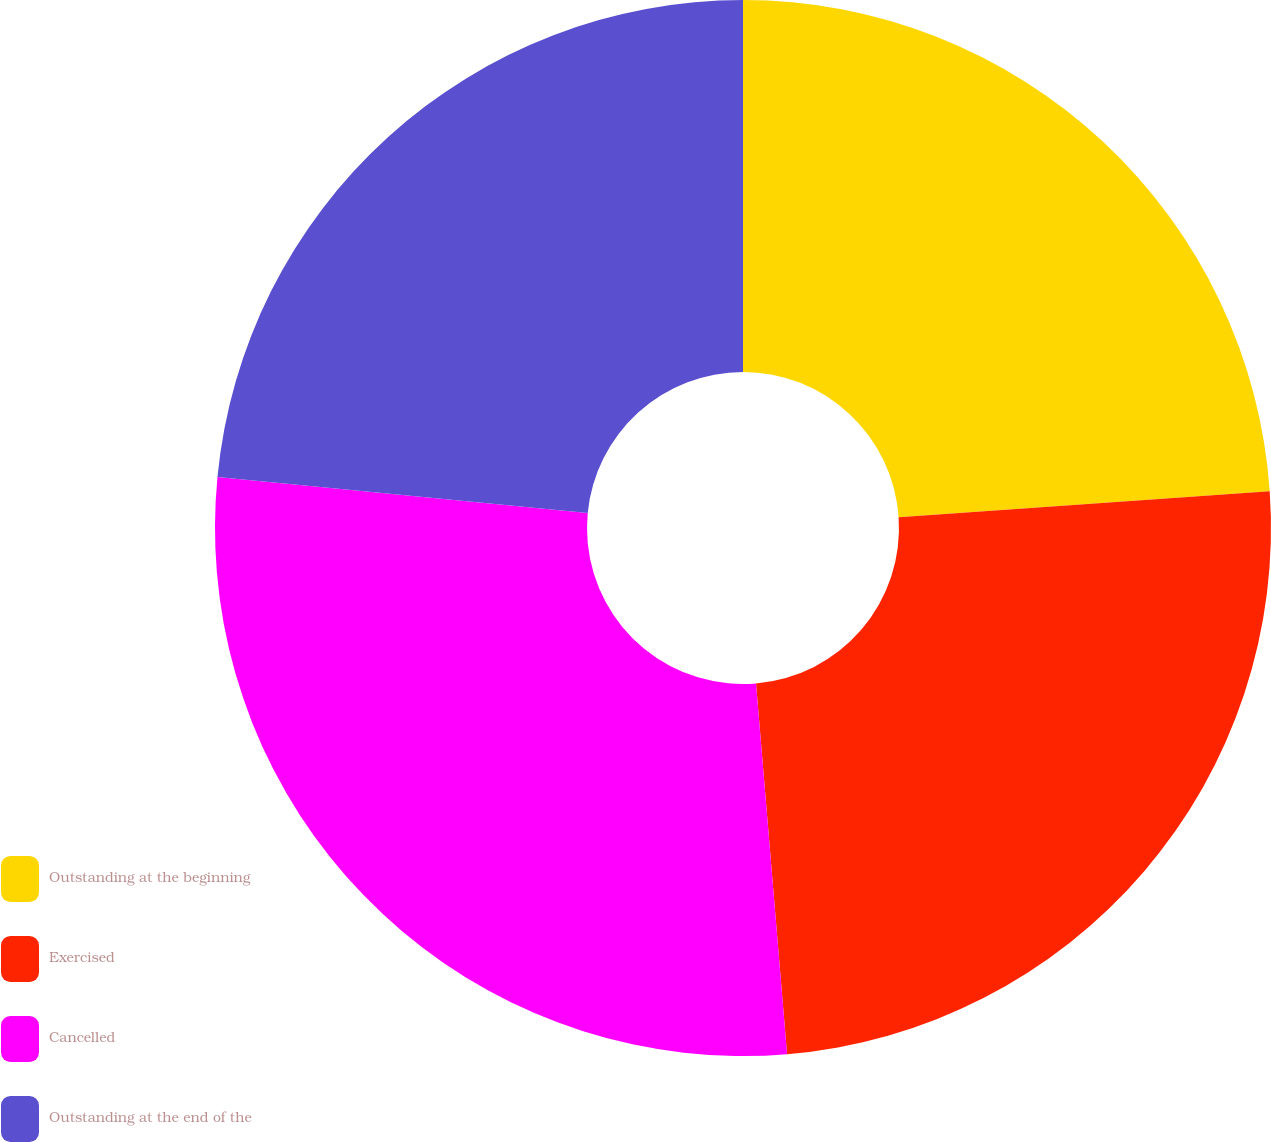<chart> <loc_0><loc_0><loc_500><loc_500><pie_chart><fcel>Outstanding at the beginning<fcel>Exercised<fcel>Cancelled<fcel>Outstanding at the end of the<nl><fcel>23.89%<fcel>24.78%<fcel>27.87%<fcel>23.46%<nl></chart> 